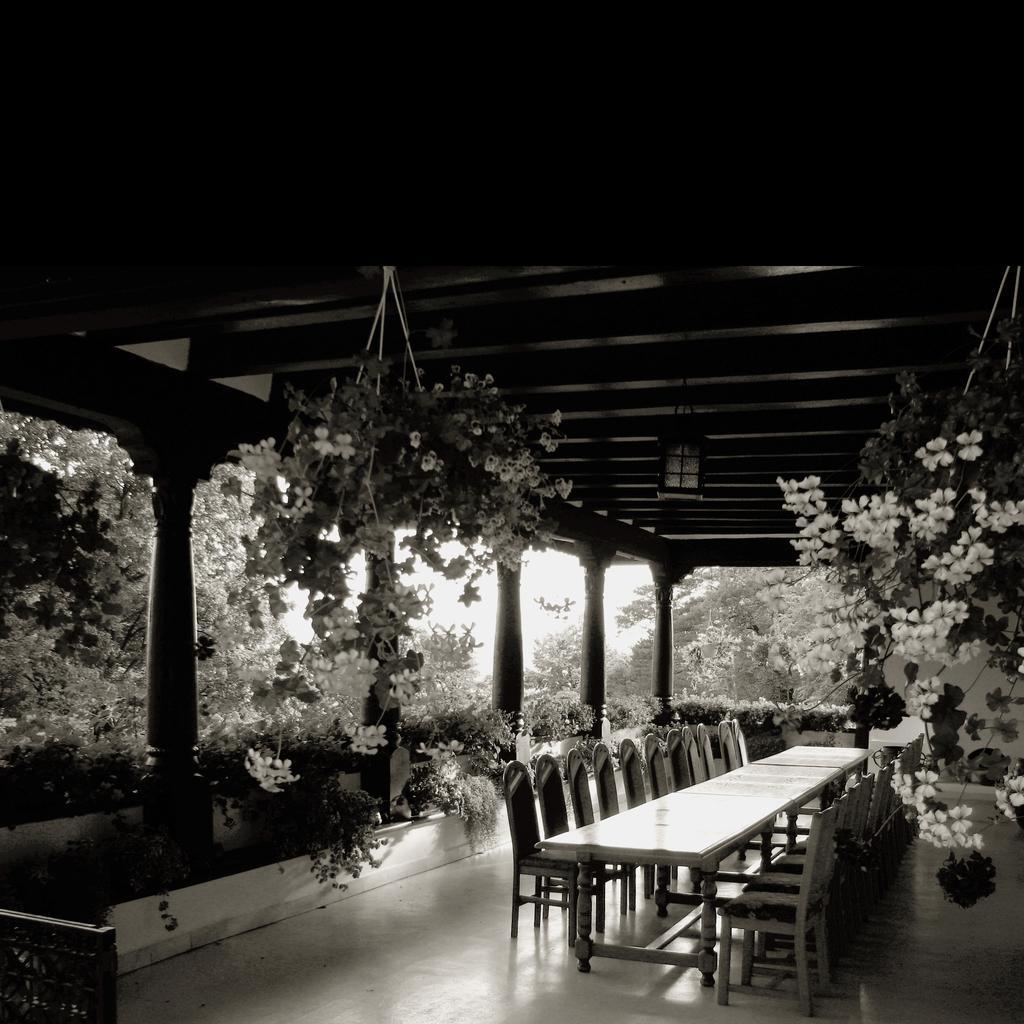In one or two sentences, can you explain what this image depicts? This is a black and white picture. At the bottom of the picture there are chairs, table, plants and wooden pillars. At the top there are flower pots and plants. In the background there are trees. 